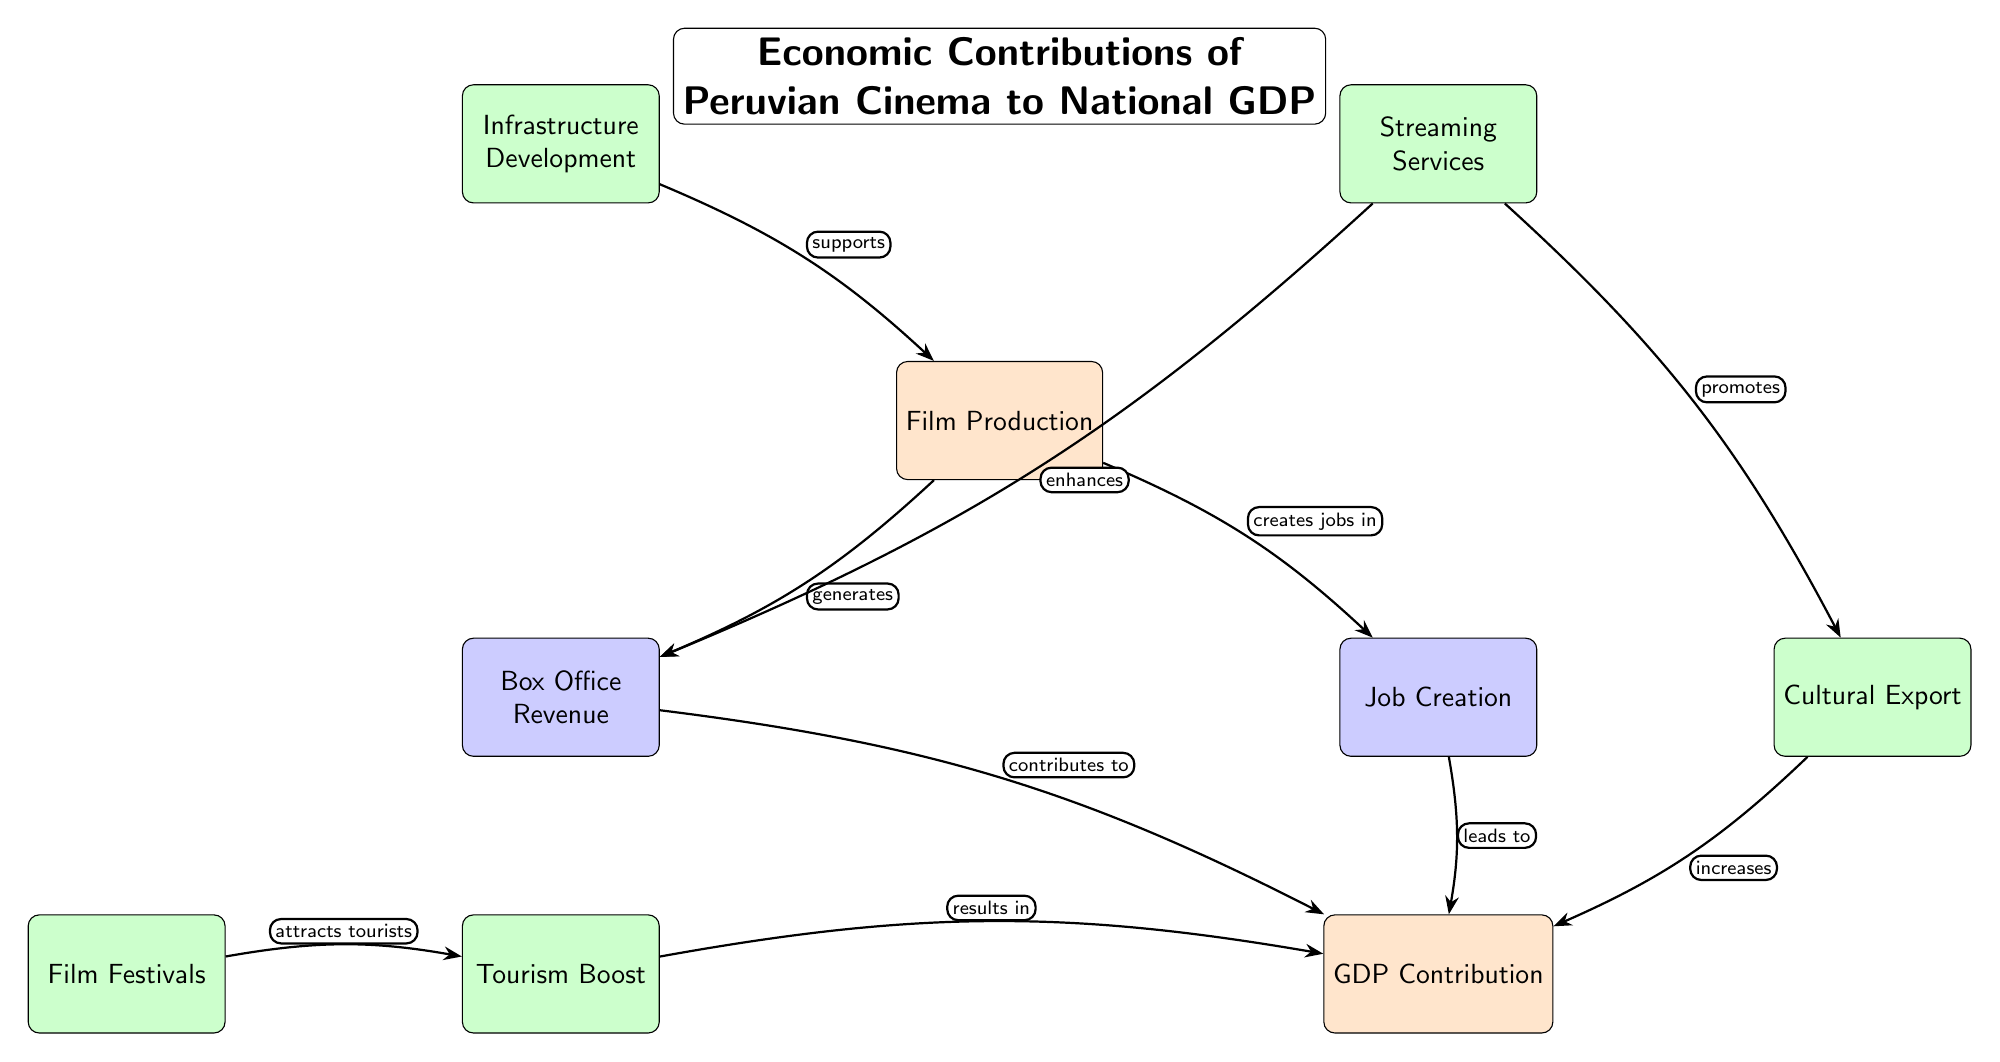What is the main node in the diagram? The main node represents the primary focus of the diagram, which is the overall economic contributions of Peruvian cinema to GDP. It is labeled "GDP Contribution."
Answer: GDP Contribution How many secondary nodes are connected to the main node? The main node has two secondary nodes directly connected to it: "Box Office Revenue" and "Job Creation." Counting these gives a total of two secondary nodes.
Answer: 2 What kind of relationship exists between "Film Production" and "Job Creation"? The edge connecting "Film Production" to "Job Creation" is labeled "creates jobs in," indicating the type of relationship where film production directly contributes to job creation.
Answer: creates jobs in Which node contributes to GDP through tourism? The node "Tourism Boost" contributes to GDP through its connection to the main node, demonstrating how tourism is linked to the economic impact of cinema.
Answer: Tourism Boost How does "Streaming Services" enhance "Box Office Revenue"? The edge from "Streaming Services" to "Box Office Revenue" is labeled "enhances," indicating that streaming services play a role in improving or increasing box office revenues for films.
Answer: enhances What are the three tertiary nodes connected to "Film Production"? The three tertiary nodes connected to "Film Production" are "Infrastructure Development," "Cultural Export," and "Streaming Services," depicting different aspects tied to film production.
Answer: Infrastructure Development, Cultural Export, Streaming Services What is the sequence of events from "Film Festivals" to "GDP Contribution"? The sequence begins with "Film Festivals," which attract tourists, leading to the "Tourism Boost" that ultimately contributes to the main node labeled "GDP Contribution." Thus, the flow is: Film Festivals → Tourism Boost → GDP Contribution.
Answer: Film Festivals → Tourism Boost → GDP Contribution What does "Cultural Export" increase? The node "Cultural Export" increases the "GDP Contribution," indicating that as cultural elements from films are exported, they positively impact the country's GDP.
Answer: GDP Contribution What impact does "Infrastructure Development" have on "Film Production"? The relationship is shown by the edge labeled "supports," meaning that infrastructure development plays a supportive role in facilitating film production activities.
Answer: supports 